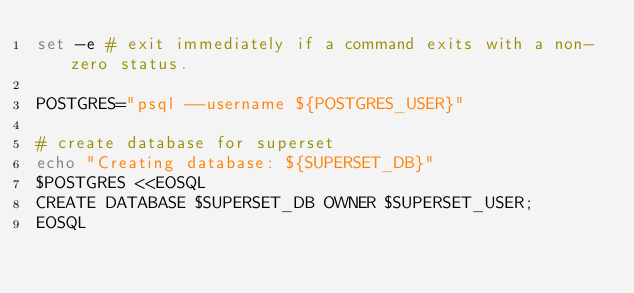Convert code to text. <code><loc_0><loc_0><loc_500><loc_500><_Bash_>set -e # exit immediately if a command exits with a non-zero status.

POSTGRES="psql --username ${POSTGRES_USER}"

# create database for superset
echo "Creating database: ${SUPERSET_DB}"
$POSTGRES <<EOSQL
CREATE DATABASE $SUPERSET_DB OWNER $SUPERSET_USER;
EOSQL</code> 